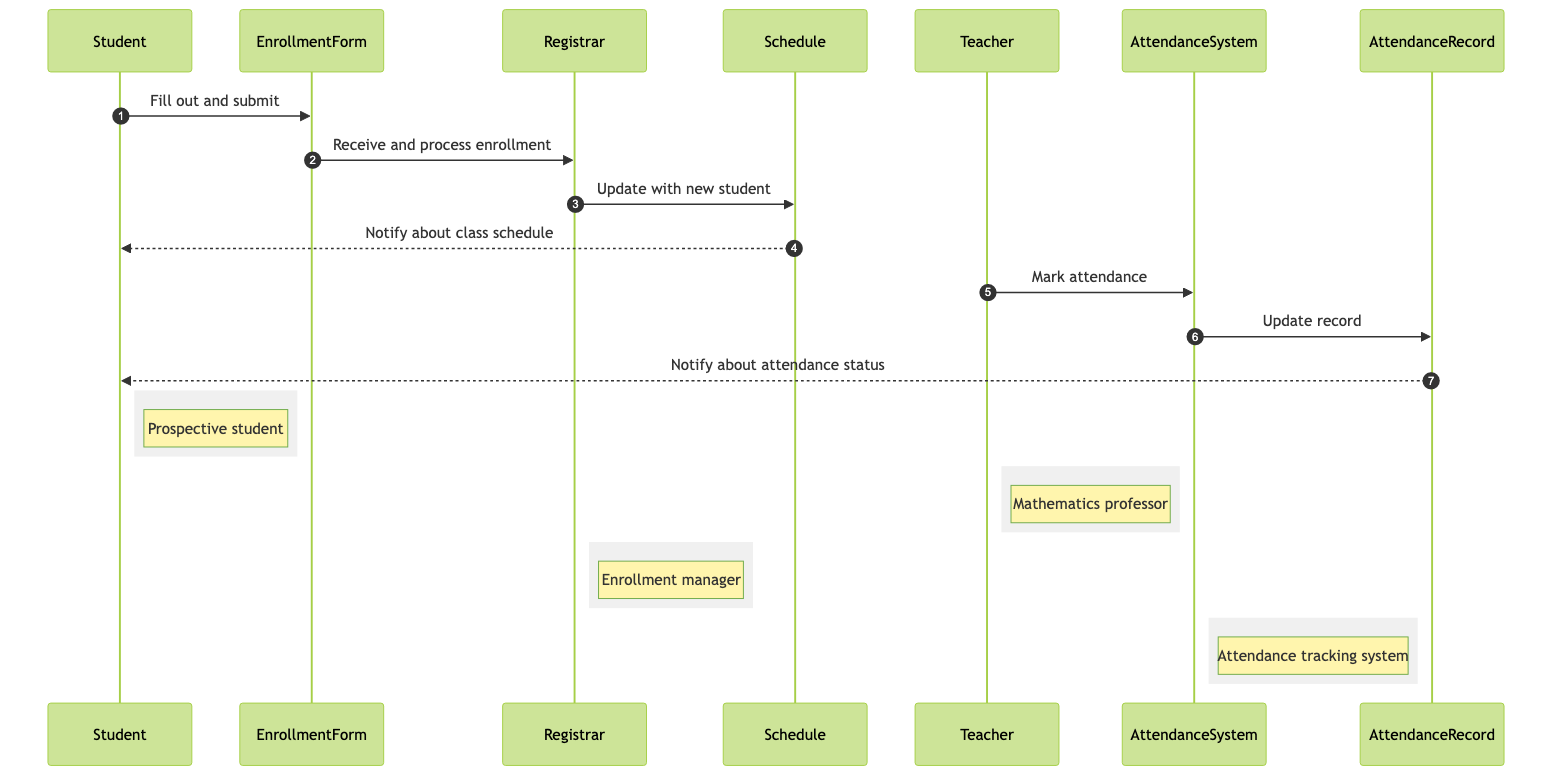What is the first action taken by the Student? The diagram shows that the first action the Student takes is to fill out and submit the EnrollmentForm. This is clear as it is the first arrow in the sequence of interactions.
Answer: Fill out and submit Who processes the enrollment after the EnrollmentForm is submitted? According to the diagram, after the Student submits the EnrollmentForm, it is received and processed by the Registrar. This is the next interaction in the sequence.
Answer: Registrar What does the Schedule notify the Student about? The Schedule notifies the Student about the class schedule, which is indicated by the arrow pointing from Schedule to Student in the diagram.
Answer: Class schedule How many main actors are involved in this sequence? The diagram lists four main actors: Student, Teacher, Registrar, and Attendance System. By counting them, we can see that there are four actors involved in this process.
Answer: Four Which actor marks attendance in the Attendance System? Looking at the diagram, the Teacher is responsible for marking attendance in the Attendance System, as shown by the interaction directed from Teacher to Attendance System.
Answer: Teacher What happens after the Attendance System updates the record? After the Attendance System updates the Attendance Record, it notifies the Student about their attendance status. This is shown as the next action following the update of the record.
Answer: Notify about attendance status What role does the EnrollmentForm play in the enrollment process? The EnrollmentForm serves as the medium that the Student uses to enroll in the programming class, which initiates the entire enrollment process by allowing the Student to input their details and submit them.
Answer: Medium for enrollment Explain the flow from the Registrar to the Schedule. The Registrar processes the enrollment and then updates the Schedule with the new student information. This flow is indicated in the diagram as an interaction from Registrar to Schedule.
Answer: Update with new student Which system records the attendance for the programming class? The Attendance System is specifically designated to record and track attendance for the programming class, as clearly labeled in the diagram.
Answer: Attendance System 